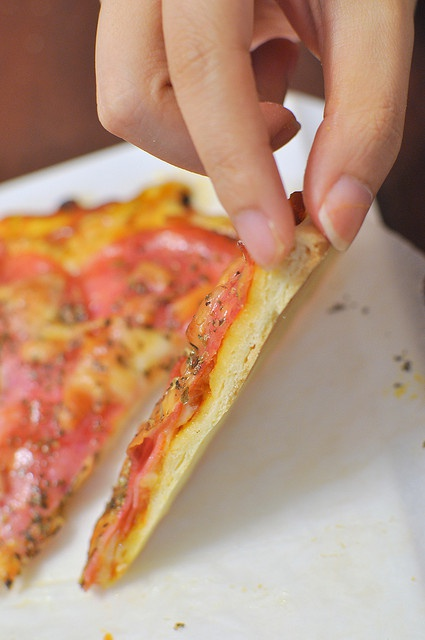Describe the objects in this image and their specific colors. I can see pizza in brown, tan, salmon, red, and orange tones and people in brown, tan, and maroon tones in this image. 